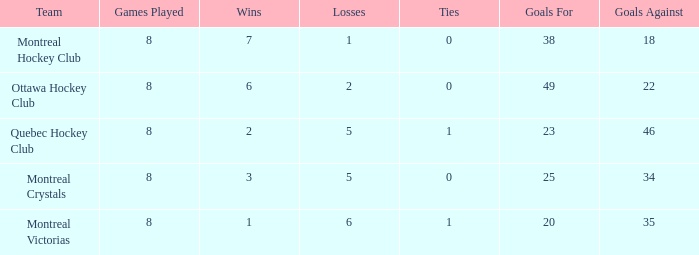What is the highest goals against when the wins is less than 1? None. 